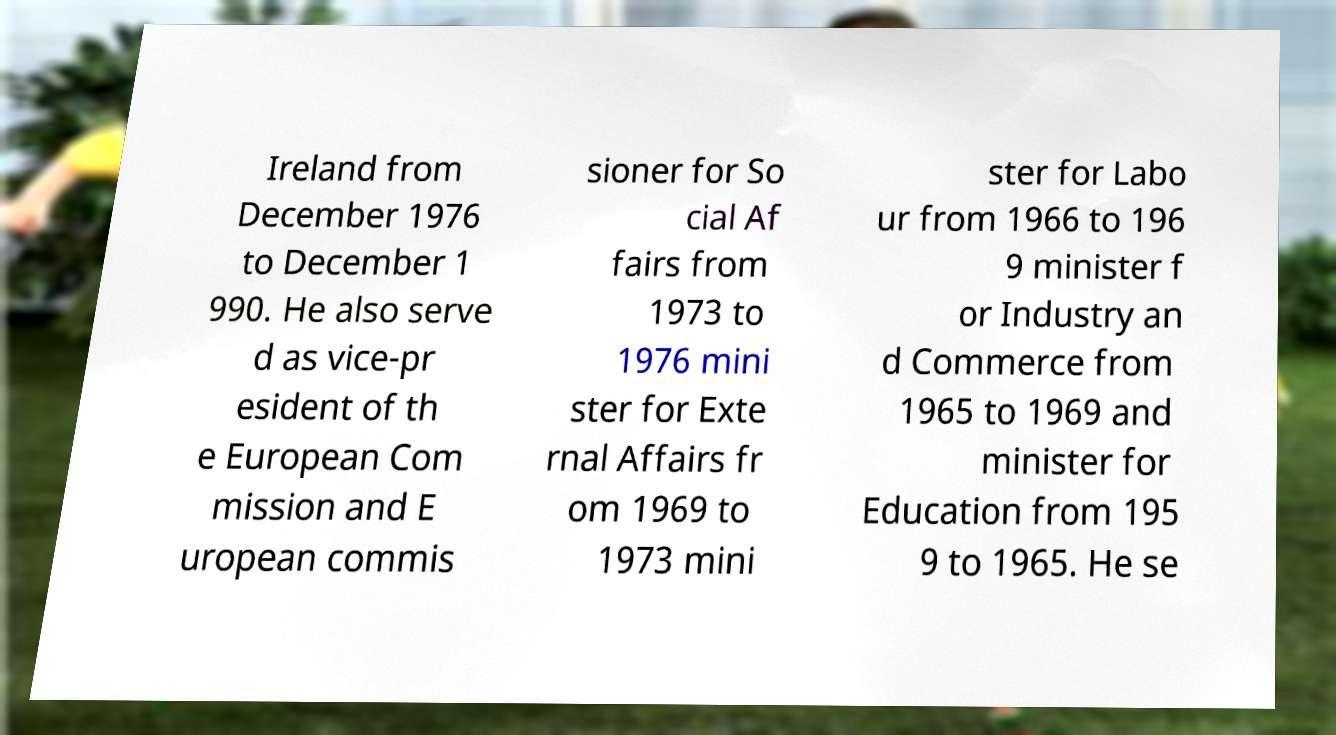Please identify and transcribe the text found in this image. Ireland from December 1976 to December 1 990. He also serve d as vice-pr esident of th e European Com mission and E uropean commis sioner for So cial Af fairs from 1973 to 1976 mini ster for Exte rnal Affairs fr om 1969 to 1973 mini ster for Labo ur from 1966 to 196 9 minister f or Industry an d Commerce from 1965 to 1969 and minister for Education from 195 9 to 1965. He se 